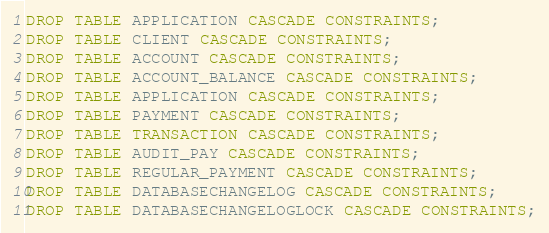Convert code to text. <code><loc_0><loc_0><loc_500><loc_500><_SQL_>DROP TABLE APPLICATION CASCADE CONSTRAINTS;
DROP TABLE CLIENT CASCADE CONSTRAINTS;
DROP TABLE ACCOUNT CASCADE CONSTRAINTS;
DROP TABLE ACCOUNT_BALANCE CASCADE CONSTRAINTS;
DROP TABLE APPLICATION CASCADE CONSTRAINTS;
DROP TABLE PAYMENT CASCADE CONSTRAINTS;
DROP TABLE TRANSACTION CASCADE CONSTRAINTS;
DROP TABLE AUDIT_PAY CASCADE CONSTRAINTS;
DROP TABLE REGULAR_PAYMENT CASCADE CONSTRAINTS;
DROP TABLE DATABASECHANGELOG CASCADE CONSTRAINTS;
DROP TABLE DATABASECHANGELOGLOCK CASCADE CONSTRAINTS;</code> 